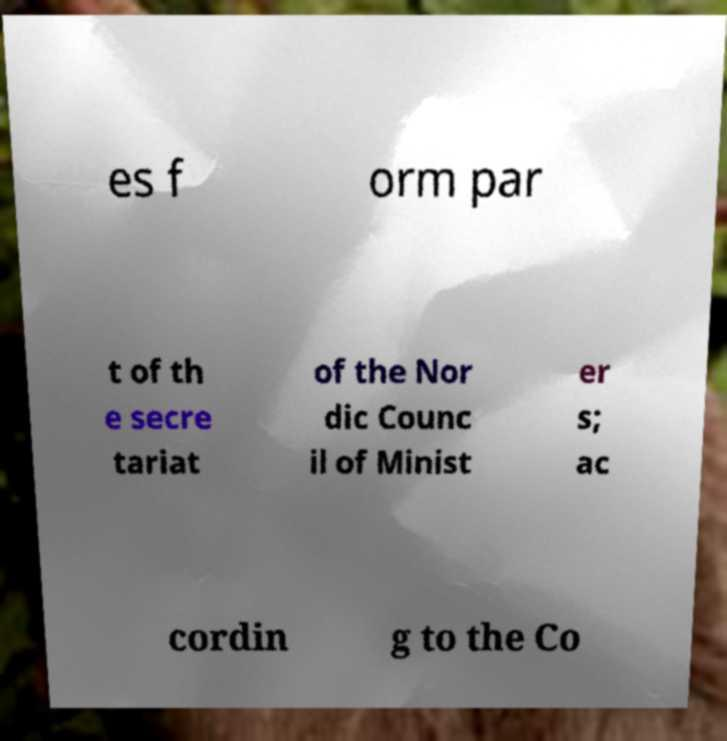Please read and relay the text visible in this image. What does it say? es f orm par t of th e secre tariat of the Nor dic Counc il of Minist er s; ac cordin g to the Co 